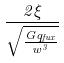Convert formula to latex. <formula><loc_0><loc_0><loc_500><loc_500>\frac { 2 \xi } { \sqrt { \frac { G q _ { f u x } } { w ^ { 3 } } } }</formula> 